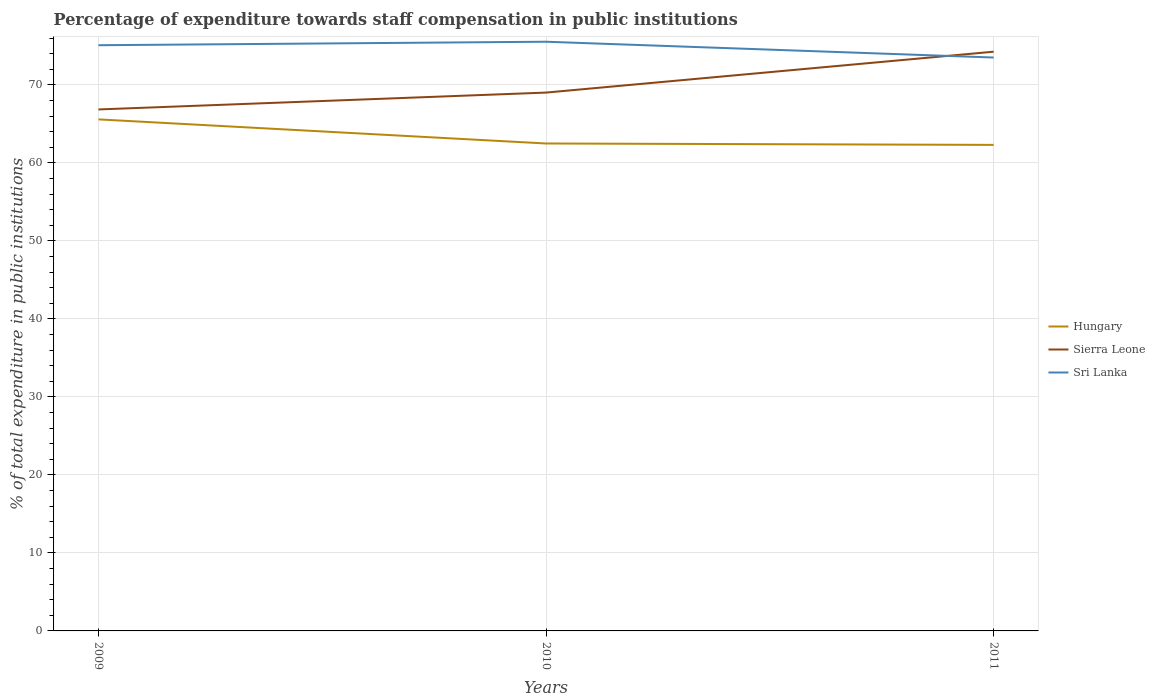Does the line corresponding to Sierra Leone intersect with the line corresponding to Hungary?
Offer a terse response. No. Across all years, what is the maximum percentage of expenditure towards staff compensation in Hungary?
Ensure brevity in your answer.  62.32. What is the total percentage of expenditure towards staff compensation in Hungary in the graph?
Your response must be concise. 3.27. What is the difference between the highest and the second highest percentage of expenditure towards staff compensation in Hungary?
Make the answer very short. 3.27. What is the difference between the highest and the lowest percentage of expenditure towards staff compensation in Sierra Leone?
Your answer should be compact. 1. Is the percentage of expenditure towards staff compensation in Sri Lanka strictly greater than the percentage of expenditure towards staff compensation in Hungary over the years?
Keep it short and to the point. No. How many years are there in the graph?
Your response must be concise. 3. What is the title of the graph?
Keep it short and to the point. Percentage of expenditure towards staff compensation in public institutions. What is the label or title of the X-axis?
Give a very brief answer. Years. What is the label or title of the Y-axis?
Provide a short and direct response. % of total expenditure in public institutions. What is the % of total expenditure in public institutions in Hungary in 2009?
Offer a very short reply. 65.59. What is the % of total expenditure in public institutions of Sierra Leone in 2009?
Ensure brevity in your answer.  66.86. What is the % of total expenditure in public institutions in Sri Lanka in 2009?
Offer a very short reply. 75.1. What is the % of total expenditure in public institutions in Hungary in 2010?
Give a very brief answer. 62.5. What is the % of total expenditure in public institutions in Sierra Leone in 2010?
Ensure brevity in your answer.  69.03. What is the % of total expenditure in public institutions in Sri Lanka in 2010?
Provide a short and direct response. 75.55. What is the % of total expenditure in public institutions in Hungary in 2011?
Offer a very short reply. 62.32. What is the % of total expenditure in public institutions in Sierra Leone in 2011?
Ensure brevity in your answer.  74.27. What is the % of total expenditure in public institutions of Sri Lanka in 2011?
Provide a short and direct response. 73.52. Across all years, what is the maximum % of total expenditure in public institutions in Hungary?
Provide a short and direct response. 65.59. Across all years, what is the maximum % of total expenditure in public institutions of Sierra Leone?
Your answer should be compact. 74.27. Across all years, what is the maximum % of total expenditure in public institutions of Sri Lanka?
Offer a terse response. 75.55. Across all years, what is the minimum % of total expenditure in public institutions of Hungary?
Your answer should be compact. 62.32. Across all years, what is the minimum % of total expenditure in public institutions in Sierra Leone?
Offer a terse response. 66.86. Across all years, what is the minimum % of total expenditure in public institutions of Sri Lanka?
Offer a very short reply. 73.52. What is the total % of total expenditure in public institutions in Hungary in the graph?
Offer a very short reply. 190.41. What is the total % of total expenditure in public institutions in Sierra Leone in the graph?
Your answer should be very brief. 210.16. What is the total % of total expenditure in public institutions in Sri Lanka in the graph?
Ensure brevity in your answer.  224.17. What is the difference between the % of total expenditure in public institutions of Hungary in 2009 and that in 2010?
Offer a very short reply. 3.09. What is the difference between the % of total expenditure in public institutions of Sierra Leone in 2009 and that in 2010?
Keep it short and to the point. -2.16. What is the difference between the % of total expenditure in public institutions in Sri Lanka in 2009 and that in 2010?
Provide a succinct answer. -0.45. What is the difference between the % of total expenditure in public institutions of Hungary in 2009 and that in 2011?
Your answer should be compact. 3.27. What is the difference between the % of total expenditure in public institutions in Sierra Leone in 2009 and that in 2011?
Offer a very short reply. -7.41. What is the difference between the % of total expenditure in public institutions of Sri Lanka in 2009 and that in 2011?
Give a very brief answer. 1.58. What is the difference between the % of total expenditure in public institutions of Hungary in 2010 and that in 2011?
Your response must be concise. 0.18. What is the difference between the % of total expenditure in public institutions of Sierra Leone in 2010 and that in 2011?
Your answer should be compact. -5.24. What is the difference between the % of total expenditure in public institutions of Sri Lanka in 2010 and that in 2011?
Give a very brief answer. 2.03. What is the difference between the % of total expenditure in public institutions in Hungary in 2009 and the % of total expenditure in public institutions in Sierra Leone in 2010?
Your answer should be compact. -3.44. What is the difference between the % of total expenditure in public institutions in Hungary in 2009 and the % of total expenditure in public institutions in Sri Lanka in 2010?
Your answer should be compact. -9.96. What is the difference between the % of total expenditure in public institutions of Sierra Leone in 2009 and the % of total expenditure in public institutions of Sri Lanka in 2010?
Provide a succinct answer. -8.68. What is the difference between the % of total expenditure in public institutions in Hungary in 2009 and the % of total expenditure in public institutions in Sierra Leone in 2011?
Provide a short and direct response. -8.68. What is the difference between the % of total expenditure in public institutions in Hungary in 2009 and the % of total expenditure in public institutions in Sri Lanka in 2011?
Ensure brevity in your answer.  -7.93. What is the difference between the % of total expenditure in public institutions in Sierra Leone in 2009 and the % of total expenditure in public institutions in Sri Lanka in 2011?
Provide a short and direct response. -6.66. What is the difference between the % of total expenditure in public institutions of Hungary in 2010 and the % of total expenditure in public institutions of Sierra Leone in 2011?
Your answer should be compact. -11.77. What is the difference between the % of total expenditure in public institutions of Hungary in 2010 and the % of total expenditure in public institutions of Sri Lanka in 2011?
Offer a very short reply. -11.02. What is the difference between the % of total expenditure in public institutions of Sierra Leone in 2010 and the % of total expenditure in public institutions of Sri Lanka in 2011?
Your answer should be very brief. -4.49. What is the average % of total expenditure in public institutions in Hungary per year?
Offer a terse response. 63.47. What is the average % of total expenditure in public institutions of Sierra Leone per year?
Your response must be concise. 70.05. What is the average % of total expenditure in public institutions of Sri Lanka per year?
Give a very brief answer. 74.72. In the year 2009, what is the difference between the % of total expenditure in public institutions of Hungary and % of total expenditure in public institutions of Sierra Leone?
Provide a short and direct response. -1.27. In the year 2009, what is the difference between the % of total expenditure in public institutions in Hungary and % of total expenditure in public institutions in Sri Lanka?
Ensure brevity in your answer.  -9.51. In the year 2009, what is the difference between the % of total expenditure in public institutions of Sierra Leone and % of total expenditure in public institutions of Sri Lanka?
Provide a succinct answer. -8.23. In the year 2010, what is the difference between the % of total expenditure in public institutions of Hungary and % of total expenditure in public institutions of Sierra Leone?
Keep it short and to the point. -6.53. In the year 2010, what is the difference between the % of total expenditure in public institutions in Hungary and % of total expenditure in public institutions in Sri Lanka?
Make the answer very short. -13.05. In the year 2010, what is the difference between the % of total expenditure in public institutions of Sierra Leone and % of total expenditure in public institutions of Sri Lanka?
Your answer should be very brief. -6.52. In the year 2011, what is the difference between the % of total expenditure in public institutions of Hungary and % of total expenditure in public institutions of Sierra Leone?
Offer a terse response. -11.95. In the year 2011, what is the difference between the % of total expenditure in public institutions in Hungary and % of total expenditure in public institutions in Sri Lanka?
Give a very brief answer. -11.2. In the year 2011, what is the difference between the % of total expenditure in public institutions of Sierra Leone and % of total expenditure in public institutions of Sri Lanka?
Provide a succinct answer. 0.75. What is the ratio of the % of total expenditure in public institutions of Hungary in 2009 to that in 2010?
Your answer should be compact. 1.05. What is the ratio of the % of total expenditure in public institutions in Sierra Leone in 2009 to that in 2010?
Offer a terse response. 0.97. What is the ratio of the % of total expenditure in public institutions of Sri Lanka in 2009 to that in 2010?
Give a very brief answer. 0.99. What is the ratio of the % of total expenditure in public institutions of Hungary in 2009 to that in 2011?
Your answer should be very brief. 1.05. What is the ratio of the % of total expenditure in public institutions in Sierra Leone in 2009 to that in 2011?
Provide a short and direct response. 0.9. What is the ratio of the % of total expenditure in public institutions in Sri Lanka in 2009 to that in 2011?
Make the answer very short. 1.02. What is the ratio of the % of total expenditure in public institutions of Hungary in 2010 to that in 2011?
Provide a succinct answer. 1. What is the ratio of the % of total expenditure in public institutions in Sierra Leone in 2010 to that in 2011?
Keep it short and to the point. 0.93. What is the ratio of the % of total expenditure in public institutions of Sri Lanka in 2010 to that in 2011?
Provide a short and direct response. 1.03. What is the difference between the highest and the second highest % of total expenditure in public institutions of Hungary?
Keep it short and to the point. 3.09. What is the difference between the highest and the second highest % of total expenditure in public institutions in Sierra Leone?
Your answer should be compact. 5.24. What is the difference between the highest and the second highest % of total expenditure in public institutions in Sri Lanka?
Keep it short and to the point. 0.45. What is the difference between the highest and the lowest % of total expenditure in public institutions of Hungary?
Offer a very short reply. 3.27. What is the difference between the highest and the lowest % of total expenditure in public institutions of Sierra Leone?
Provide a short and direct response. 7.41. What is the difference between the highest and the lowest % of total expenditure in public institutions in Sri Lanka?
Provide a short and direct response. 2.03. 